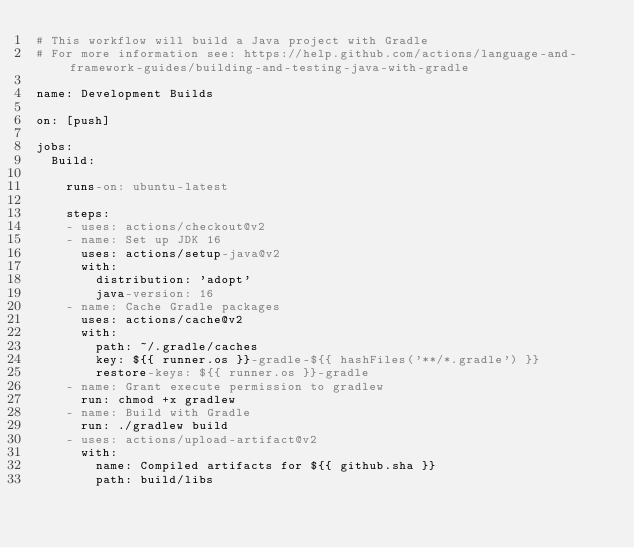<code> <loc_0><loc_0><loc_500><loc_500><_YAML_># This workflow will build a Java project with Gradle
# For more information see: https://help.github.com/actions/language-and-framework-guides/building-and-testing-java-with-gradle

name: Development Builds

on: [push]

jobs:
  Build:

    runs-on: ubuntu-latest

    steps:
    - uses: actions/checkout@v2
    - name: Set up JDK 16
      uses: actions/setup-java@v2
      with:
        distribution: 'adopt'
        java-version: 16
    - name: Cache Gradle packages
      uses: actions/cache@v2
      with:
        path: ~/.gradle/caches
        key: ${{ runner.os }}-gradle-${{ hashFiles('**/*.gradle') }}
        restore-keys: ${{ runner.os }}-gradle
    - name: Grant execute permission to gradlew
      run: chmod +x gradlew
    - name: Build with Gradle
      run: ./gradlew build
    - uses: actions/upload-artifact@v2
      with:
        name: Compiled artifacts for ${{ github.sha }}
        path: build/libs
</code> 